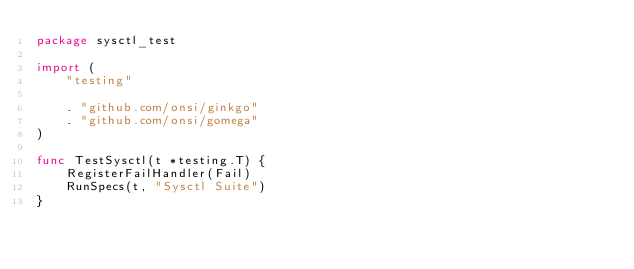<code> <loc_0><loc_0><loc_500><loc_500><_Go_>package sysctl_test

import (
	"testing"

	. "github.com/onsi/ginkgo"
	. "github.com/onsi/gomega"
)

func TestSysctl(t *testing.T) {
	RegisterFailHandler(Fail)
	RunSpecs(t, "Sysctl Suite")
}
</code> 